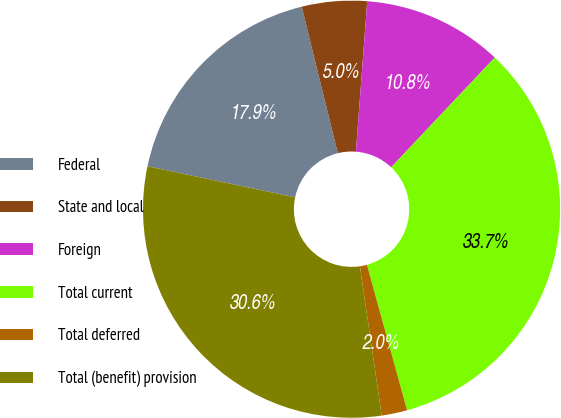Convert chart. <chart><loc_0><loc_0><loc_500><loc_500><pie_chart><fcel>Federal<fcel>State and local<fcel>Foreign<fcel>Total current<fcel>Total deferred<fcel>Total (benefit) provision<nl><fcel>17.86%<fcel>5.04%<fcel>10.85%<fcel>33.67%<fcel>1.98%<fcel>30.61%<nl></chart> 